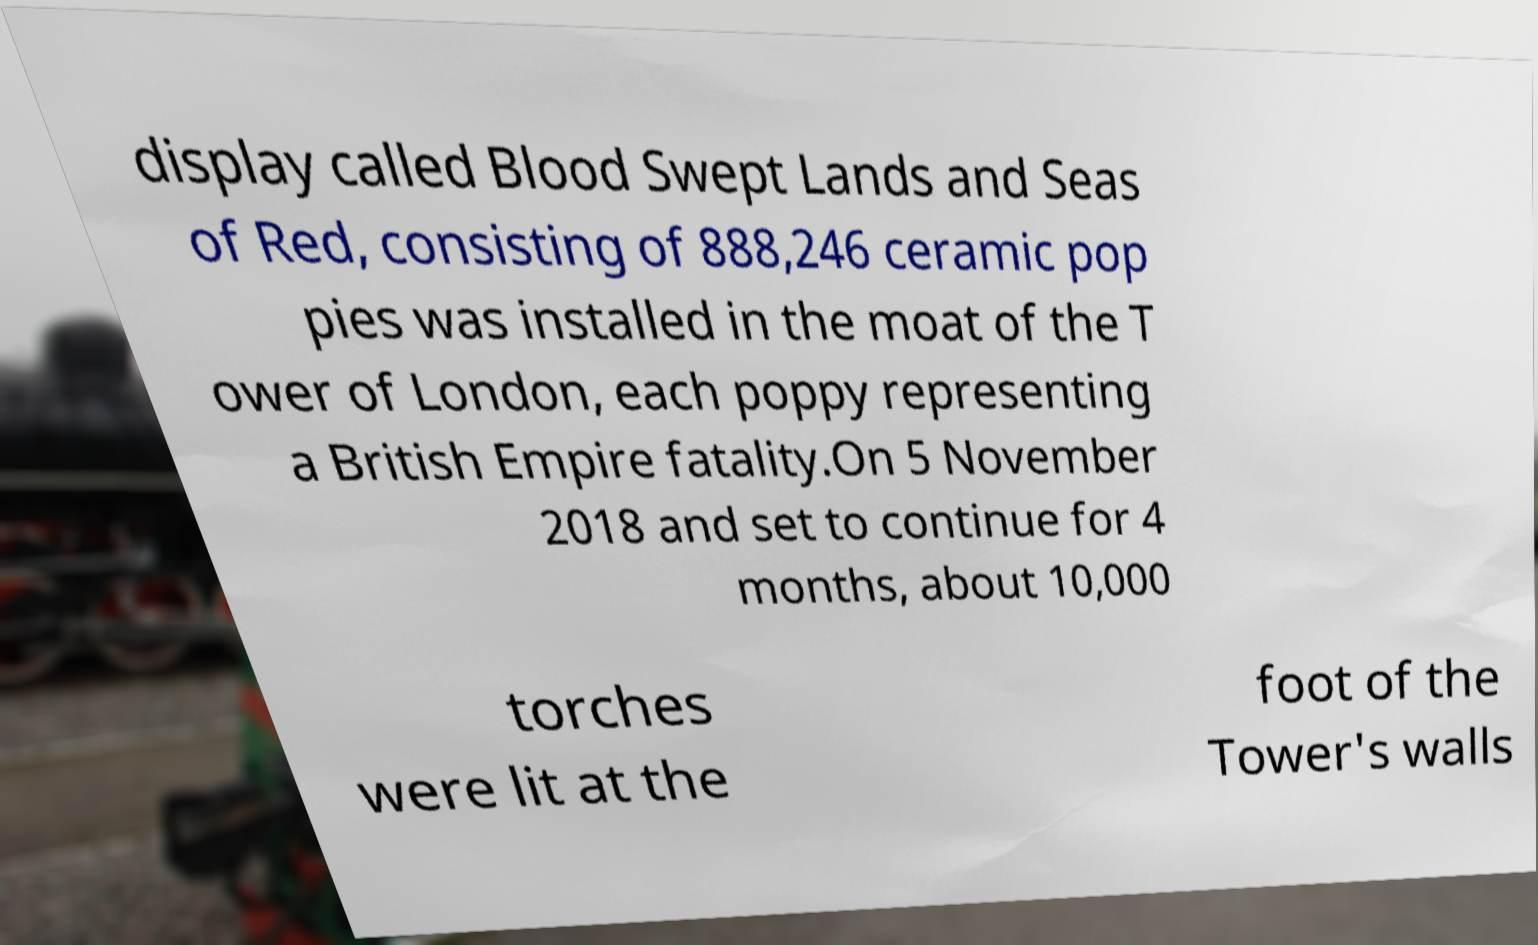There's text embedded in this image that I need extracted. Can you transcribe it verbatim? display called Blood Swept Lands and Seas of Red, consisting of 888,246 ceramic pop pies was installed in the moat of the T ower of London, each poppy representing a British Empire fatality.On 5 November 2018 and set to continue for 4 months, about 10,000 torches were lit at the foot of the Tower's walls 